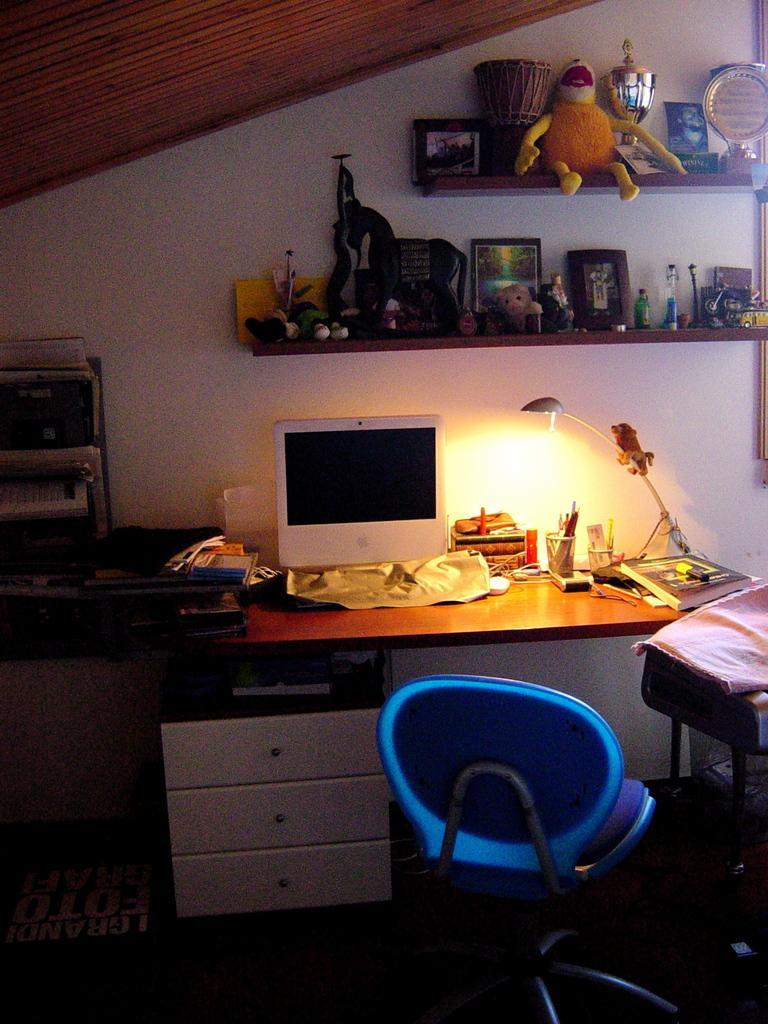How would you summarize this image in a sentence or two? In this image I can see a chair and a monitor on this table. I can also see few stuffs over here. 